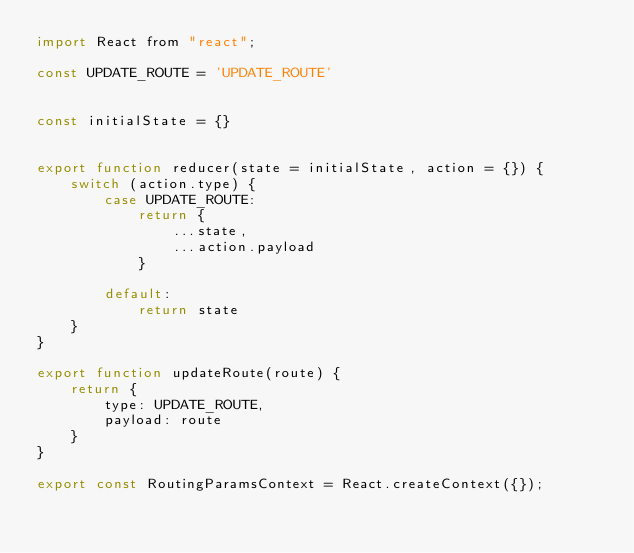Convert code to text. <code><loc_0><loc_0><loc_500><loc_500><_JavaScript_>import React from "react";

const UPDATE_ROUTE = 'UPDATE_ROUTE'


const initialState = {}


export function reducer(state = initialState, action = {}) {
    switch (action.type) {
        case UPDATE_ROUTE:
            return {
                ...state,
                ...action.payload
            }

        default:
            return state
    }
}

export function updateRoute(route) {
    return {
        type: UPDATE_ROUTE,
        payload: route
    }
}

export const RoutingParamsContext = React.createContext({});
</code> 